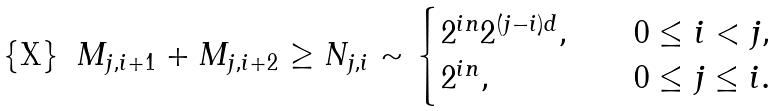Convert formula to latex. <formula><loc_0><loc_0><loc_500><loc_500>M _ { j , i + 1 } + M _ { j , i + 2 } \geq N _ { j , i } \sim \begin{cases} 2 ^ { i n } 2 ^ { ( j - i ) d } , \quad & 0 \leq i < j , \\ 2 ^ { i n } , & 0 \leq j \leq i . \end{cases}</formula> 